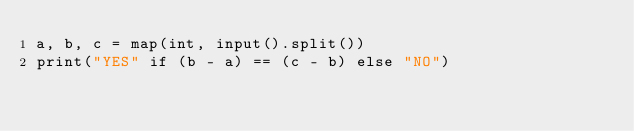<code> <loc_0><loc_0><loc_500><loc_500><_Python_>a, b, c = map(int, input().split())
print("YES" if (b - a) == (c - b) else "NO")</code> 